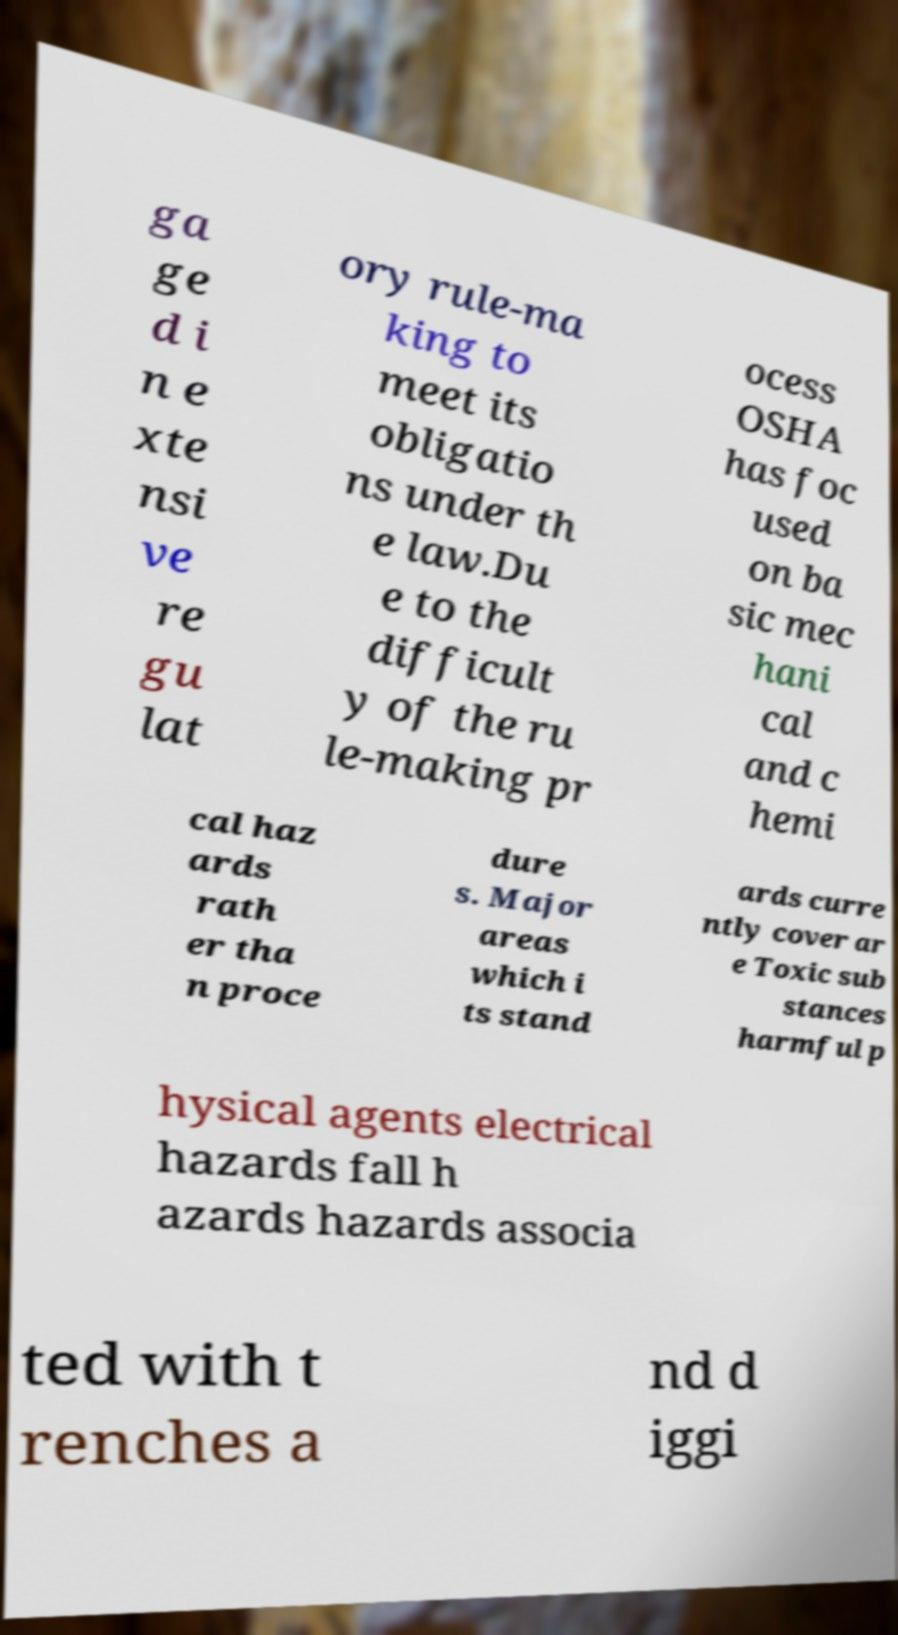There's text embedded in this image that I need extracted. Can you transcribe it verbatim? ga ge d i n e xte nsi ve re gu lat ory rule-ma king to meet its obligatio ns under th e law.Du e to the difficult y of the ru le-making pr ocess OSHA has foc used on ba sic mec hani cal and c hemi cal haz ards rath er tha n proce dure s. Major areas which i ts stand ards curre ntly cover ar e Toxic sub stances harmful p hysical agents electrical hazards fall h azards hazards associa ted with t renches a nd d iggi 